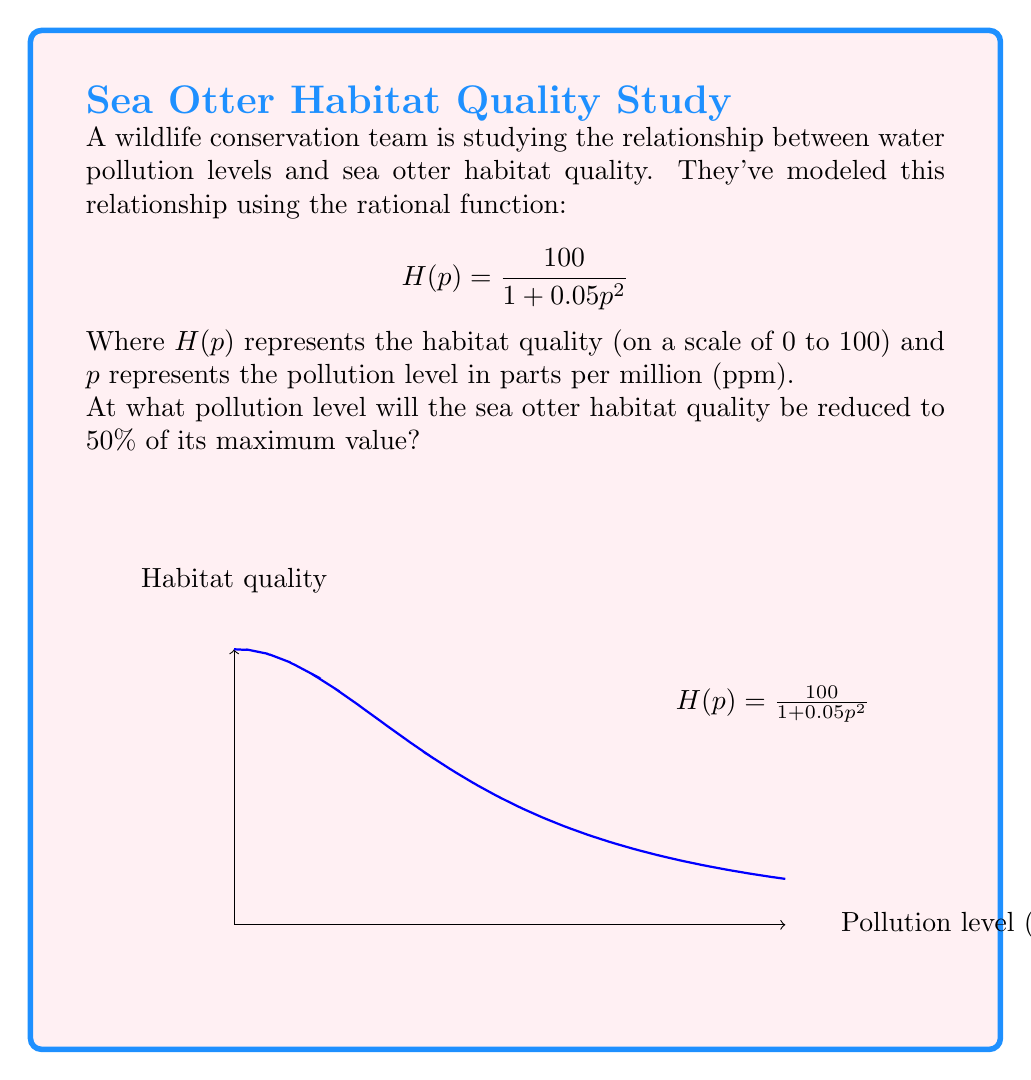Give your solution to this math problem. Let's approach this step-by-step:

1) The maximum habitat quality occurs when pollution is at its minimum (0 ppm). We can calculate this:

   $$H(0) = \frac{100}{1 + 0.05(0)^2} = \frac{100}{1} = 100$$

   So the maximum habitat quality is 100.

2) We're looking for the pollution level where the habitat quality is 50% of its maximum. That means:

   $$H(p) = 0.5 \times 100 = 50$$

3) Now we can set up our equation:

   $$\frac{100}{1 + 0.05p^2} = 50$$

4) Multiply both sides by $(1 + 0.05p^2)$:

   $$100 = 50(1 + 0.05p^2)$$

5) Distribute on the right side:

   $$100 = 50 + 2.5p^2$$

6) Subtract 50 from both sides:

   $$50 = 2.5p^2$$

7) Divide both sides by 2.5:

   $$20 = p^2$$

8) Take the square root of both sides:

   $$p = \sqrt{20} \approx 4.47$$

Therefore, the pollution level that reduces habitat quality to 50% is approximately 4.47 ppm.
Answer: $\sqrt{20}$ ppm or approximately 4.47 ppm 